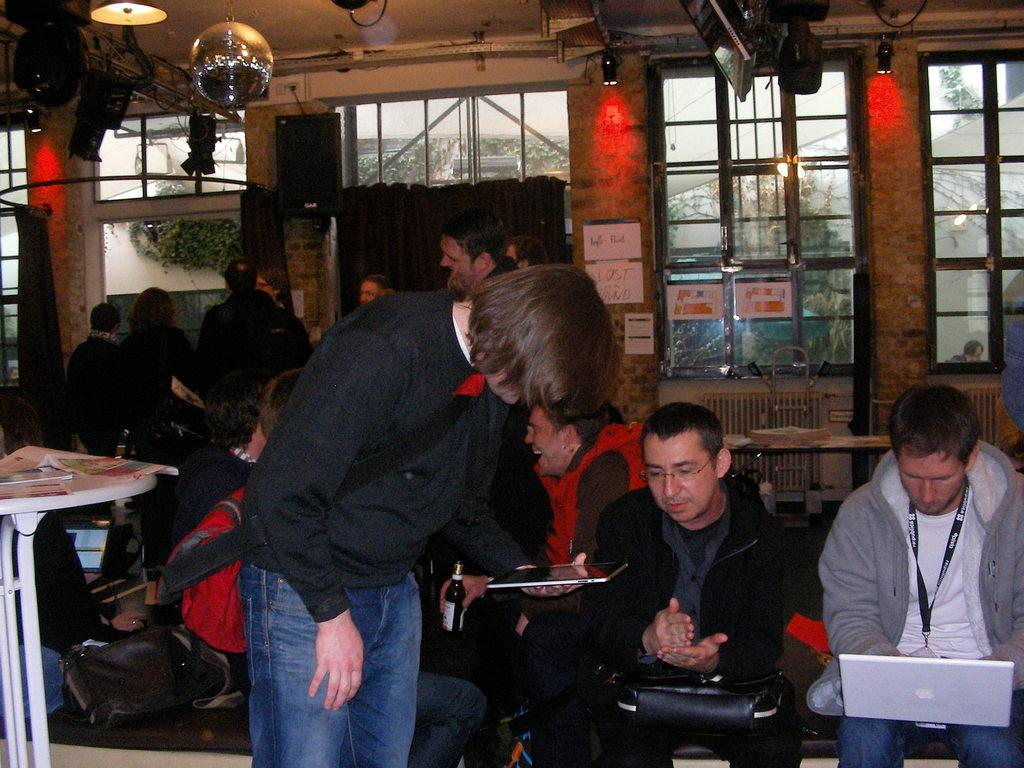How many people are in the image? There are people in the image, but the exact number is not specified. What are the people doing in the image? Some people are sitting, while most are standing. What can be seen on the wall in the image? There are lights and windows on the wall. What type of pancake is being served at the event in the image? There is no event or pancake present in the image. What color is the shirt of the person standing in the image? The facts do not mention any specific colors or shirts worn by the people in the image. 